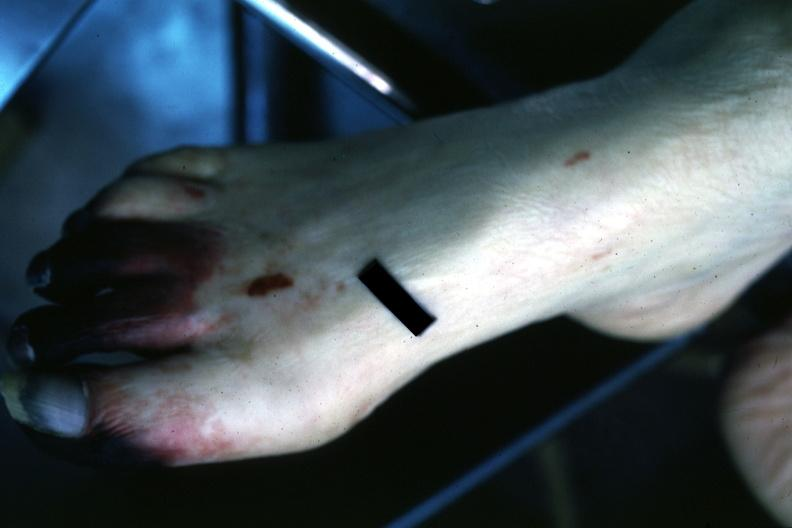what are present?
Answer the question using a single word or phrase. Extremities 